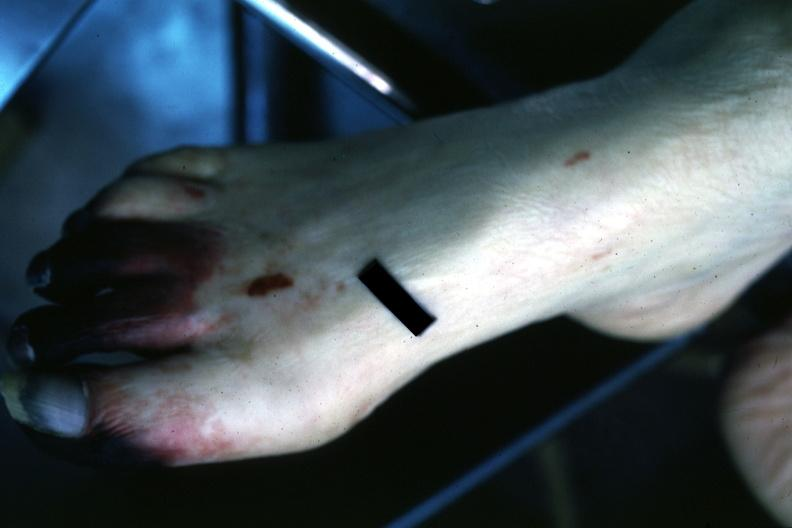what are present?
Answer the question using a single word or phrase. Extremities 